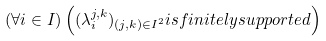Convert formula to latex. <formula><loc_0><loc_0><loc_500><loc_500>( \forall i \in I ) \left ( ( \lambda _ { i } ^ { j , k } ) _ { ( j , k ) \in I ^ { 2 } } i s f i n i t e l y s u p p o r t e d \right )</formula> 